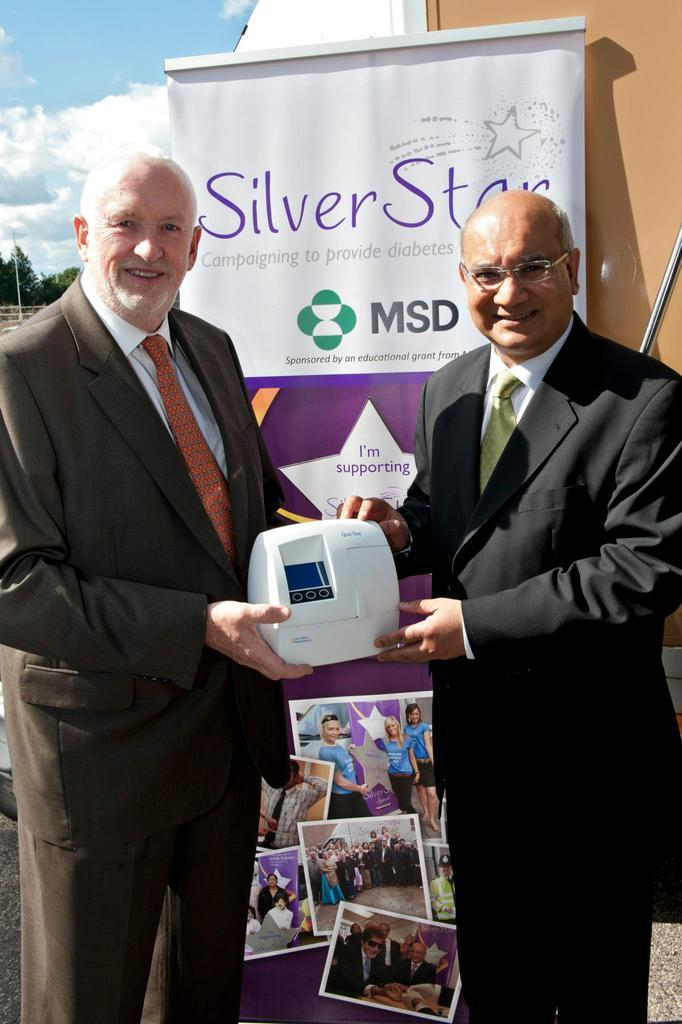How many people are in the image? There are two people in the image. What are the people holding in the image? The people are holding something, but the specific object is not mentioned in the facts. What can be seen on the wall in the image? There is a poster in the image. What is written or depicted on the poster? The poster has text and pictures on it. What type of soap is being used to create friction between the people in the image? There is no soap or friction present in the image; the people are simply holding something. 